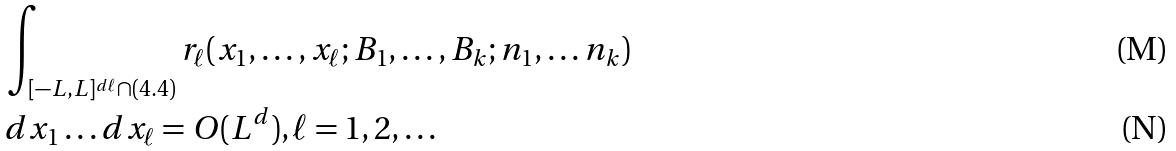<formula> <loc_0><loc_0><loc_500><loc_500>& \int _ { [ - L , L ] ^ { d \ell } \cap ( 4 . 4 ) } r _ { \ell } ( x _ { 1 } , \dots , x _ { \ell } ; B _ { 1 } , \dots , B _ { k } ; n _ { 1 } , \dots n _ { k } ) \\ & d x _ { 1 } \dots d x _ { \ell } = O ( L ^ { d } ) , \ell = 1 , 2 , \dots</formula> 